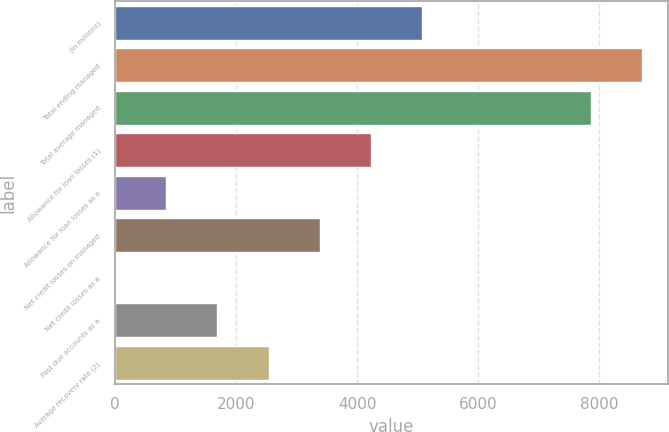<chart> <loc_0><loc_0><loc_500><loc_500><bar_chart><fcel>(In millions)<fcel>Total ending managed<fcel>Total average managed<fcel>Allowance for loan losses (1)<fcel>Allowance for loan losses as a<fcel>Net credit losses on managed<fcel>Net credit losses as a<fcel>Past due accounts as a<fcel>Average recovery rate (2)<nl><fcel>5075.58<fcel>8705.68<fcel>7859.9<fcel>4229.8<fcel>846.68<fcel>3384.02<fcel>0.9<fcel>1692.46<fcel>2538.24<nl></chart> 